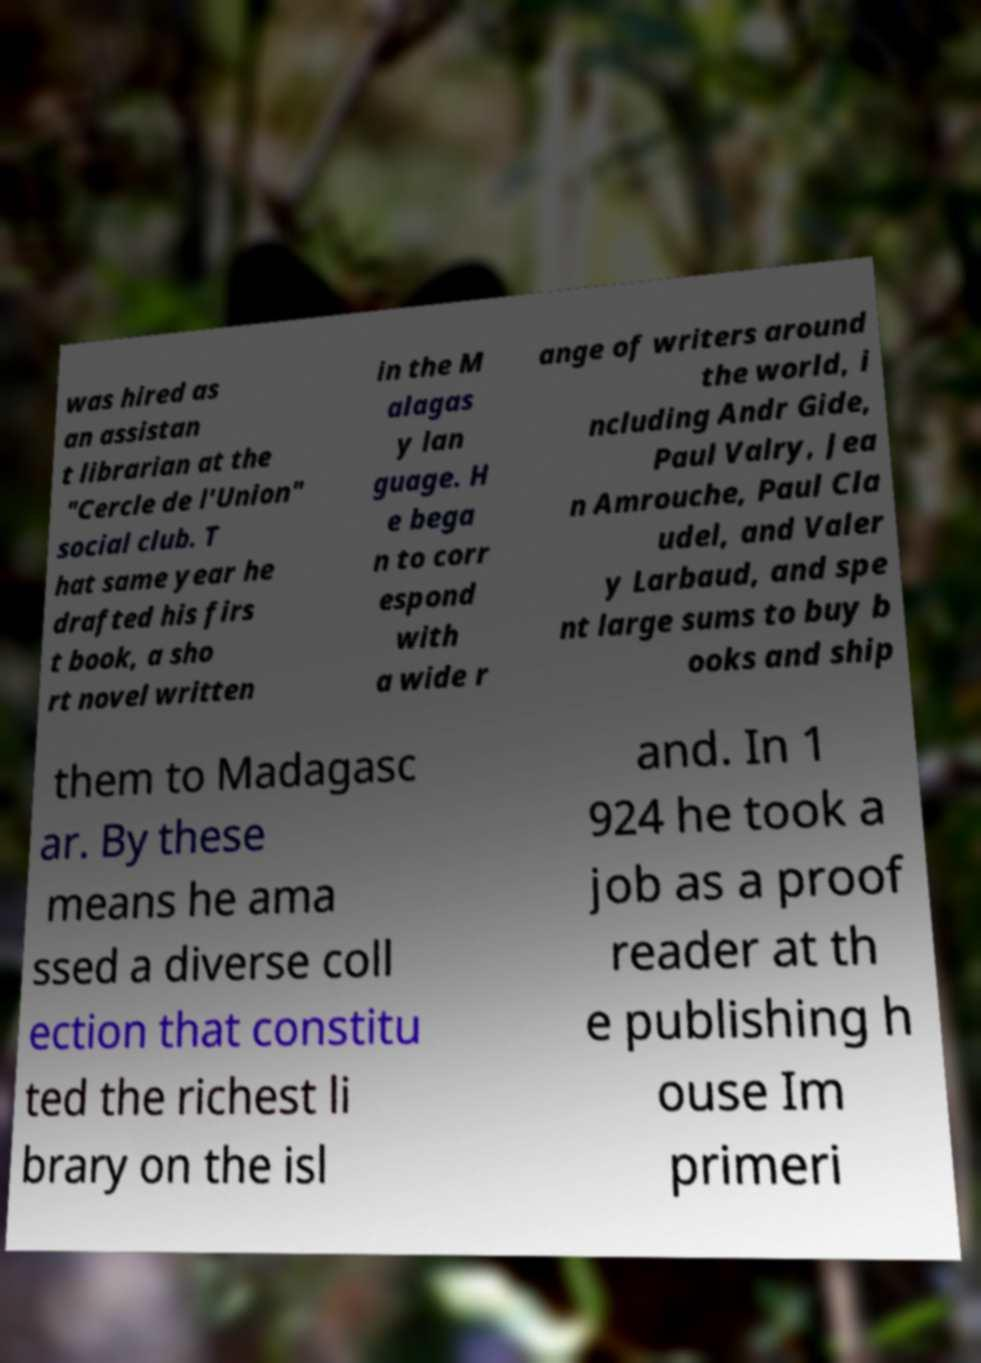For documentation purposes, I need the text within this image transcribed. Could you provide that? was hired as an assistan t librarian at the "Cercle de l'Union" social club. T hat same year he drafted his firs t book, a sho rt novel written in the M alagas y lan guage. H e bega n to corr espond with a wide r ange of writers around the world, i ncluding Andr Gide, Paul Valry, Jea n Amrouche, Paul Cla udel, and Valer y Larbaud, and spe nt large sums to buy b ooks and ship them to Madagasc ar. By these means he ama ssed a diverse coll ection that constitu ted the richest li brary on the isl and. In 1 924 he took a job as a proof reader at th e publishing h ouse Im primeri 